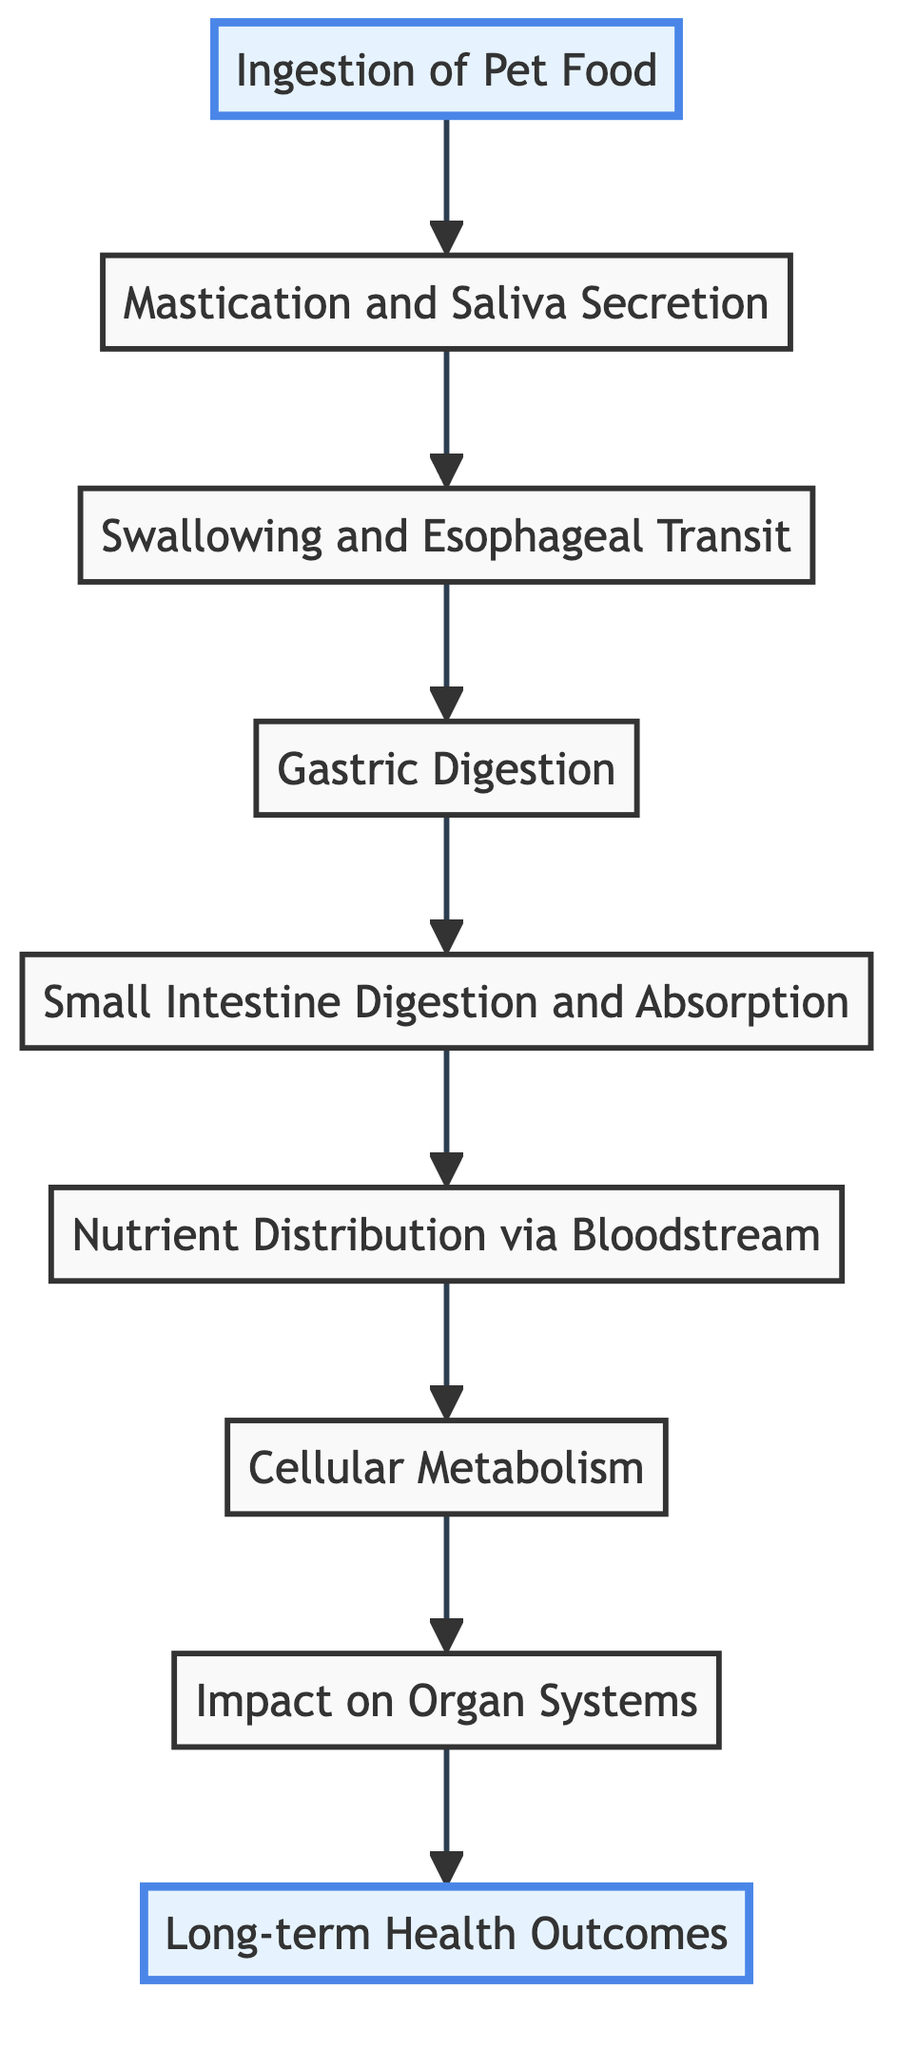What is the first step in the nutrition absorption process? The diagram indicates that the first step, at the bottom, is "Ingestion of Pet Food," which represents the initial consumption of dog food by various breeds.
Answer: Ingestion of Pet Food Which node follows the "Gastric Digestion" step? According to the flow, the node that directly follows "Gastric Digestion" is "Small Intestine Digestion and Absorption," indicating the progression to the next stage of the digestion process.
Answer: Small Intestine Digestion and Absorption How many total nodes are present in this flowchart? By counting each distinct step in the flowchart, we identify a total of 9 nodes: Ingestion of Pet Food, Mastication and Saliva Secretion, Swallowing and Esophageal Transit, Gastric Digestion, Small Intestine Digestion and Absorption, Nutrient Distribution via Bloodstream, Cellular Metabolism, Impact on Organ Systems, and Long-term Health Outcomes.
Answer: 9 What is the final outcome indicated in the diagram? The flowchart leads to "Long-term Health Outcomes," which is positioned at the top and signifies the ultimate result of the entire nutrition absorption process on canine health.
Answer: Long-term Health Outcomes Which step describes the movement of food from the mouth to the stomach? In the diagram, the step that details this process is "Swallowing and Esophageal Transit," highlighting the transition of food after mastication.
Answer: Swallowing and Esophageal Transit How does "Cellular Metabolism" relate to "Nutrient Distribution via Bloodstream"? The flowchart illustrates that "Nutrient Distribution via Bloodstream" occurs before "Cellular Metabolism," implying that nutrients are first distributed throughout the body before utilization at the cellular level.
Answer: Nutrient Distribution via Bloodstream Which organ systems are impacted by nutrition, according to the diagram? The node labeled "Impact on Organ Systems" outlines that nutrition affects key systems such as the liver, kidneys, heart, and muscles, indicating the broad influence of pet food on various bodily functions.
Answer: Liver, kidneys, heart, muscles What process occurs immediately after "Small Intestine Digestion and Absorption"? The subsequent process following "Small Intestine Digestion and Absorption" is "Nutrient Distribution via Bloodstream," showing that after the nutrients are absorbed, they are then transported to different parts of the body.
Answer: Nutrient Distribution via Bloodstream What is the relationship between "Cellular Metabolism" and "Long-term Health Outcomes"? The flowchart indicates that "Cellular Metabolism" directly feeds into "Impact on Organ Systems," which then leads to "Long-term Health Outcomes," establishing a causal link where proper metabolism impacts overall health.
Answer: Causal link 